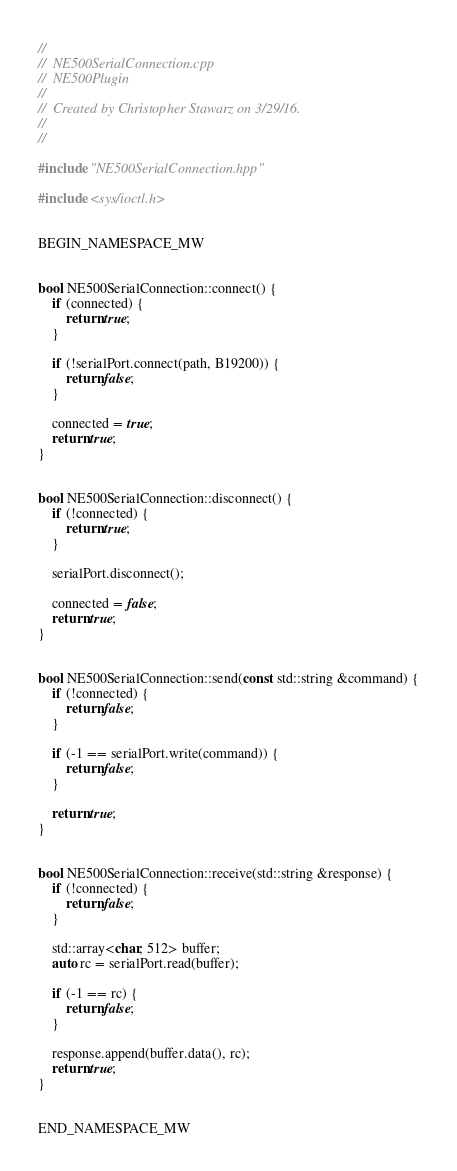<code> <loc_0><loc_0><loc_500><loc_500><_C++_>//
//  NE500SerialConnection.cpp
//  NE500Plugin
//
//  Created by Christopher Stawarz on 3/29/16.
//
//

#include "NE500SerialConnection.hpp"

#include <sys/ioctl.h>


BEGIN_NAMESPACE_MW


bool NE500SerialConnection::connect() {
    if (connected) {
        return true;
    }
    
    if (!serialPort.connect(path, B19200)) {
        return false;
    }
    
    connected = true;
    return true;
}


bool NE500SerialConnection::disconnect() {
    if (!connected) {
        return true;
    }
    
    serialPort.disconnect();
    
    connected = false;
    return true;
}


bool NE500SerialConnection::send(const std::string &command) {
    if (!connected) {
        return false;
    }
    
    if (-1 == serialPort.write(command)) {
        return false;
    }
    
    return true;
}


bool NE500SerialConnection::receive(std::string &response) {
    if (!connected) {
        return false;
    }
    
    std::array<char, 512> buffer;
    auto rc = serialPort.read(buffer);
    
    if (-1 == rc) {
        return false;
    }
    
    response.append(buffer.data(), rc);
    return true;
}


END_NAMESPACE_MW



























</code> 